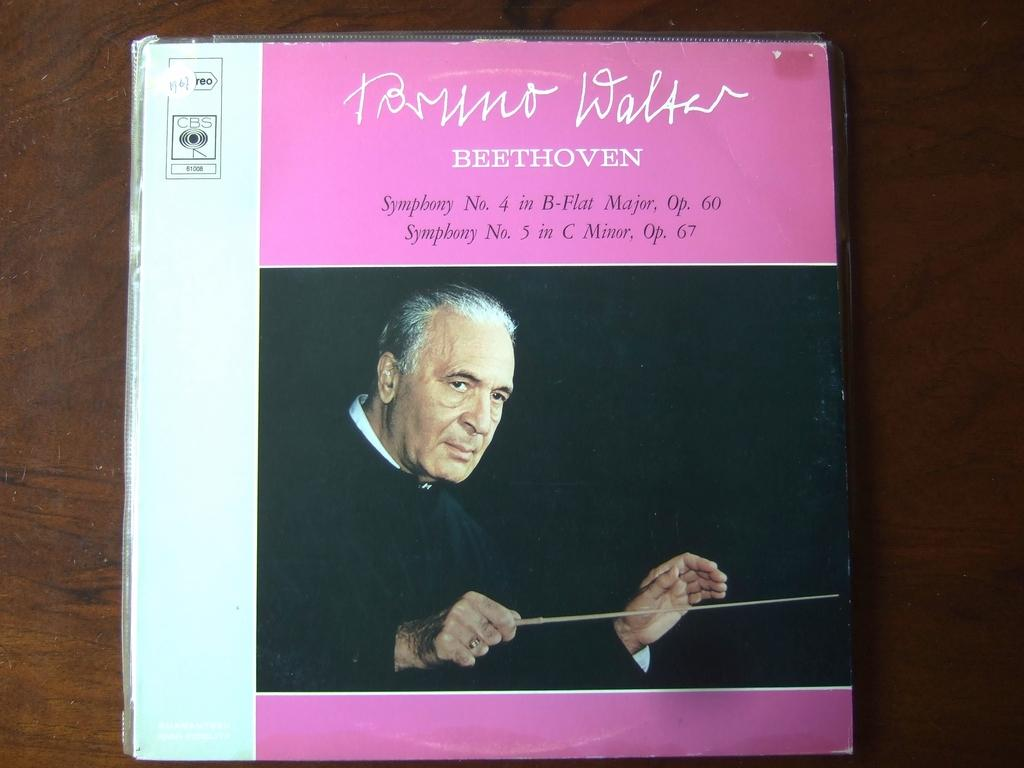Provide a one-sentence caption for the provided image. An pink and white album box set of Beethoven's Symponies 4 and 5. 